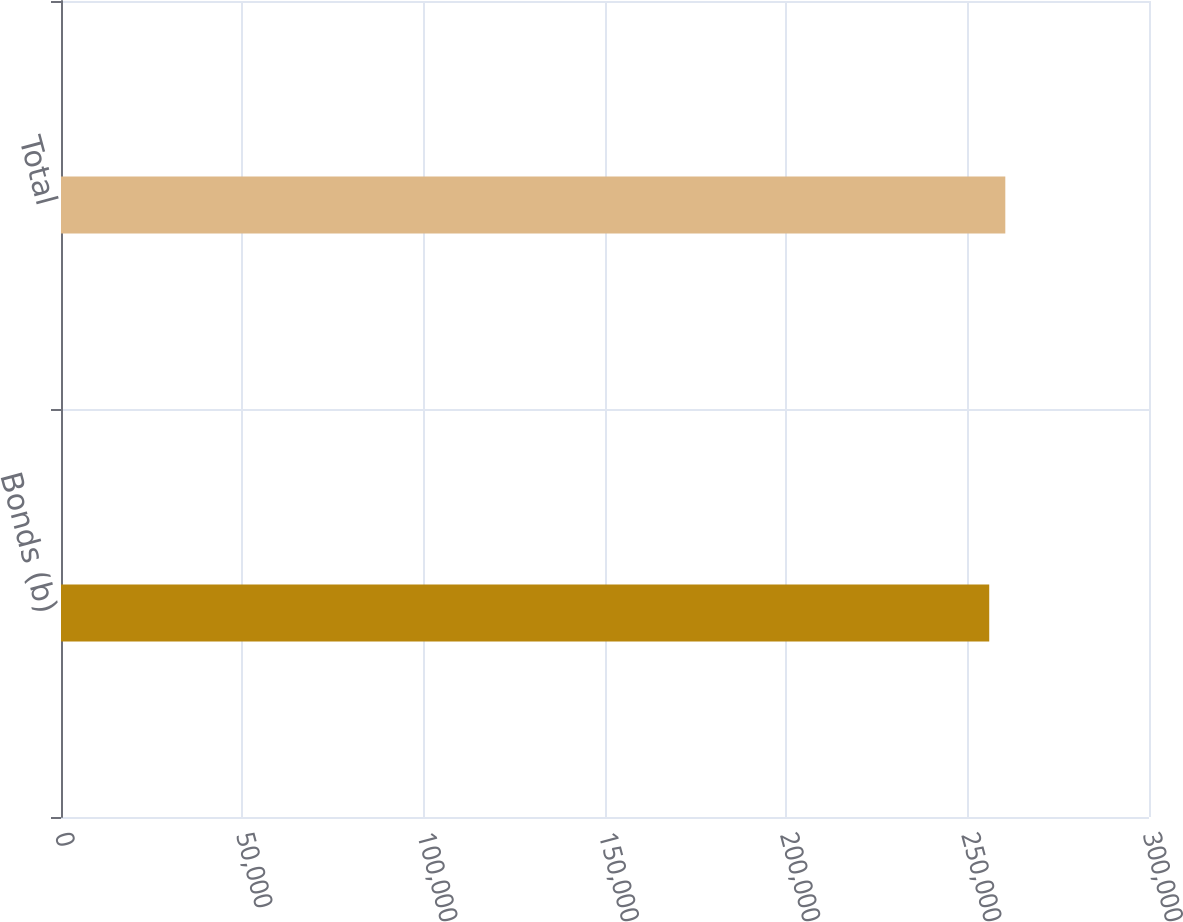Convert chart. <chart><loc_0><loc_0><loc_500><loc_500><bar_chart><fcel>Bonds (b)<fcel>Total<nl><fcel>255946<fcel>260379<nl></chart> 